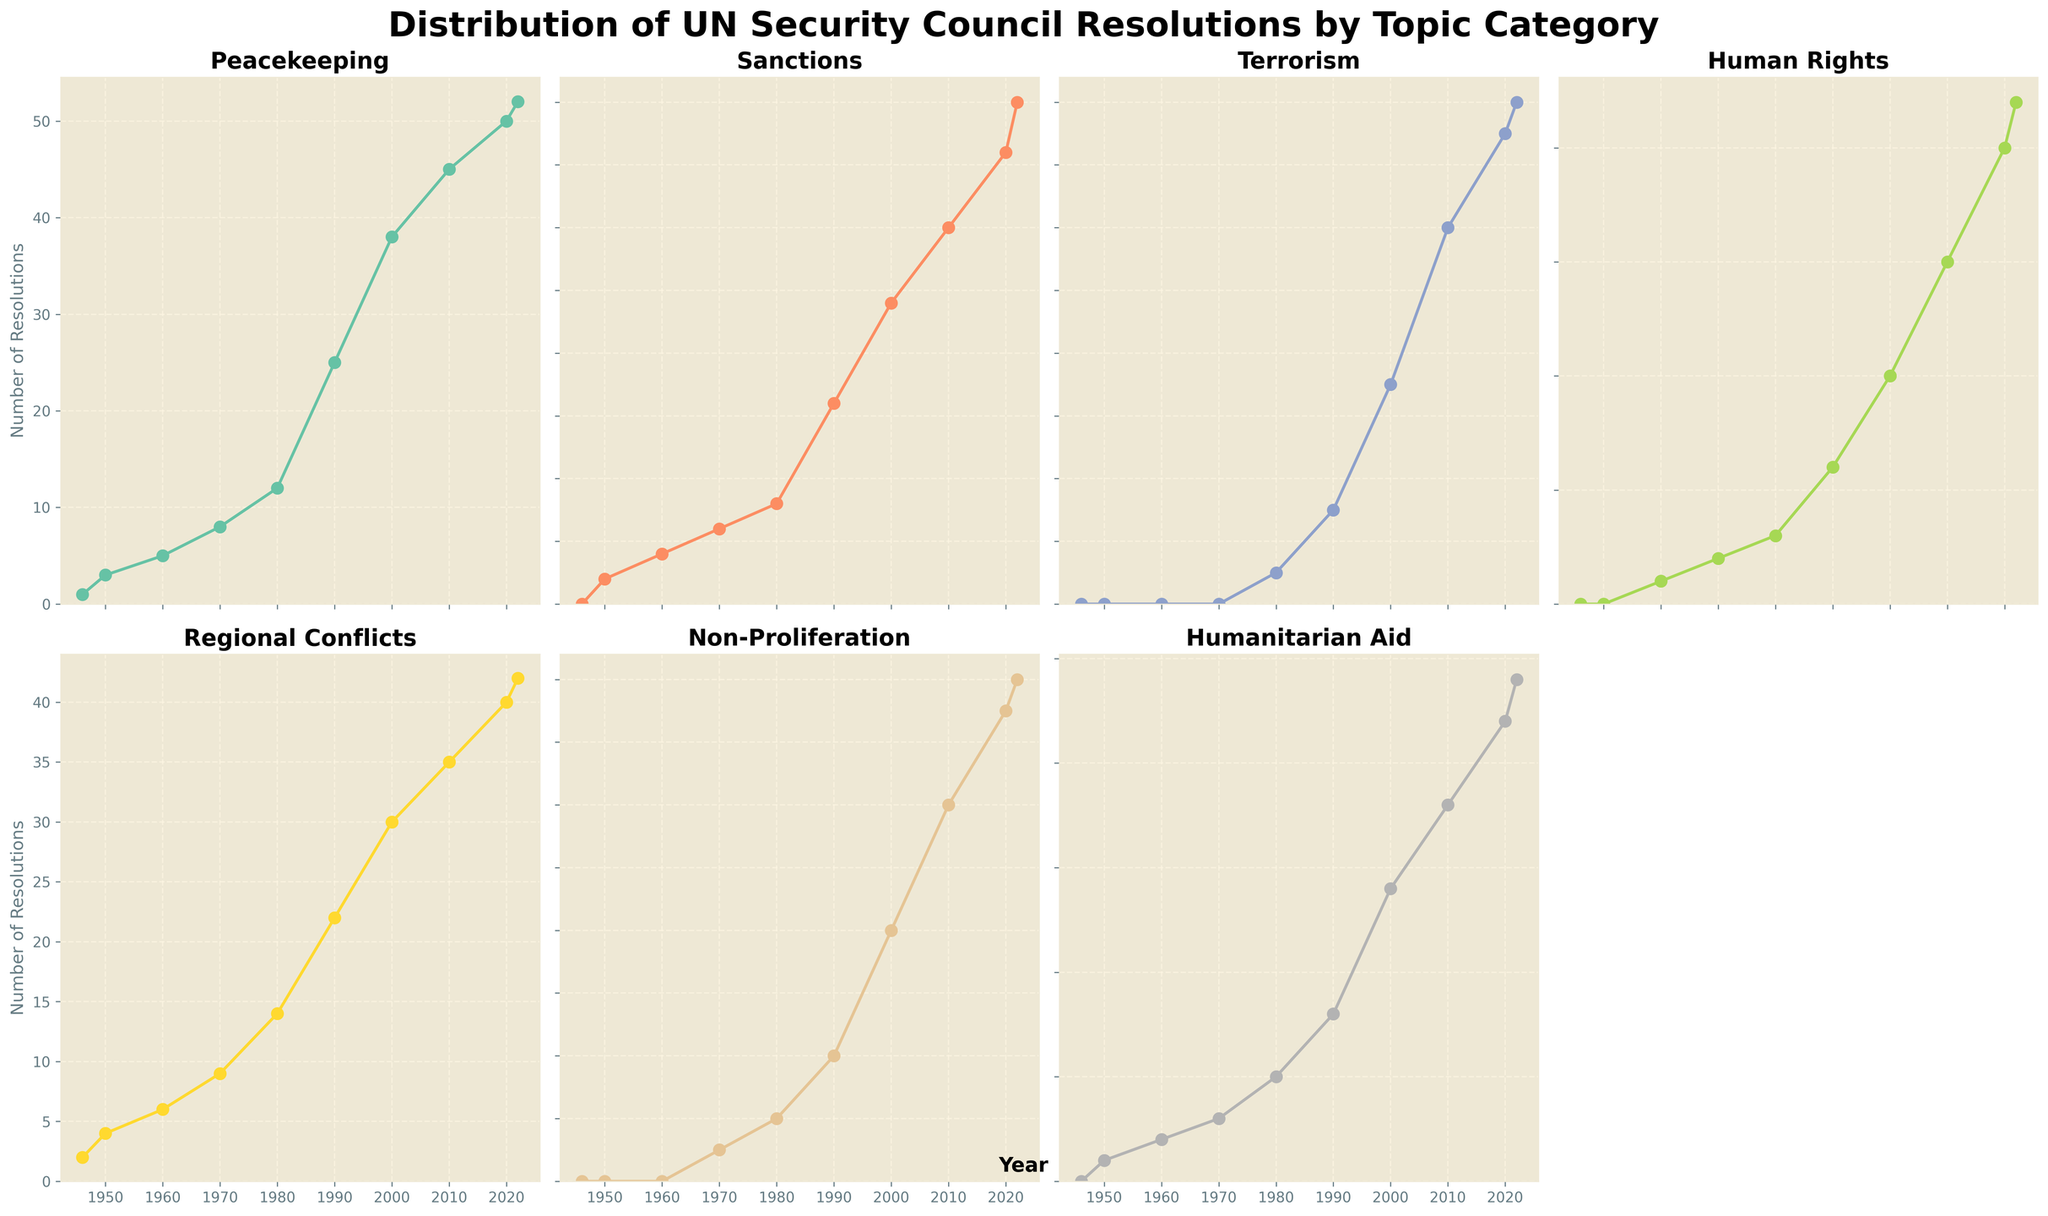What's the trend in the number of resolutions on Human Rights from 1946 to 2022? By examining the plot for Human Rights, we observe a steady increase in the number of resolutions over time. Starting at 0 in 1946, it climbs to about 22 in 2022, indicating a growing focus on Human Rights issues.
Answer: Increases steadily What is the difference between resolutions on Peacekeeping and Terrorism in 2022? Looking at the 2022 data points for both Peacekeeping and Terrorism, Peacekeeping has 52 resolutions while Terrorism has 16. To find the difference, subtract 16 from 52 (52 - 16).
Answer: 36 Which category had the highest number of resolutions in the 1980s? In the plot for the 1980 data, Regional Conflicts had the highest at 14 resolutions compared to other categories such as Peacekeeping (12), Sanctions (4), Terrorism (1), and others.
Answer: Regional Conflicts How many total resolutions were passed in 1990 across all categories? Summing up the 1990 data for each category: Peacekeeping (25), Sanctions (8), Terrorism (3), Human Rights (6), Regional Conflicts (22), Non-Proliferation (4), and Humanitarian Aid (8). The total is 76.
Answer: 76 Between which years did Non-Proliferation experience its first increase? Observing the plot for Non-Proliferation, we see the first increase occurs between 1960 (0) and 1970 (1).
Answer: Between 1960 and 1970 Which category shows the most gradual increase in resolutions from 1946 to 2022? The plots show that Terrorism resolutions demonstrate the most gradual increase over the years, starting at 0 and reaching 16 in 2022 with small incremental changes compared to other categories.
Answer: Terrorism How many resolutions on Humanitarian Aid were there in the year 2000? Referring to the plot for Humanitarian Aid, in the year 2000, there were 14 resolutions.
Answer: 14 What is the average number of resolutions on Sanctions from 1946 to 2022? Adding the number of resolutions for Sanctions over the given years (0, 1, 2, 3, 4, 8, 12, 15, 18, 20) and dividing by the number of years (10), the average is (83/10) = 8.3.
Answer: 8.3 How does the increase in Peacekeeping resolutions compare to Humanitarian Aid from 1946 to 2022? Peacekeeping resolutions rose from 1 in 1946 to 52 in 2022, an increase of 51. Humanitarian Aid resolutions rose from 0 to 24, an increase of 24. This shows that Peacekeeping resolutions increased more substantially than Humanitarian Aid.
Answer: Peacekeeping increased more Is there any category that did not have resolutions until after 1980? By examining the plots, we see that Terrorism did not have any resolutions until 1980, making it the category with no resolutions before that period.
Answer: Terrorism 